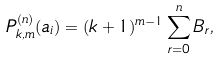<formula> <loc_0><loc_0><loc_500><loc_500>P ^ { ( n ) } _ { k , m } ( a _ { i } ) & = ( k + 1 ) ^ { m - 1 } \sum _ { r = 0 } ^ { n } B _ { r } , \\</formula> 